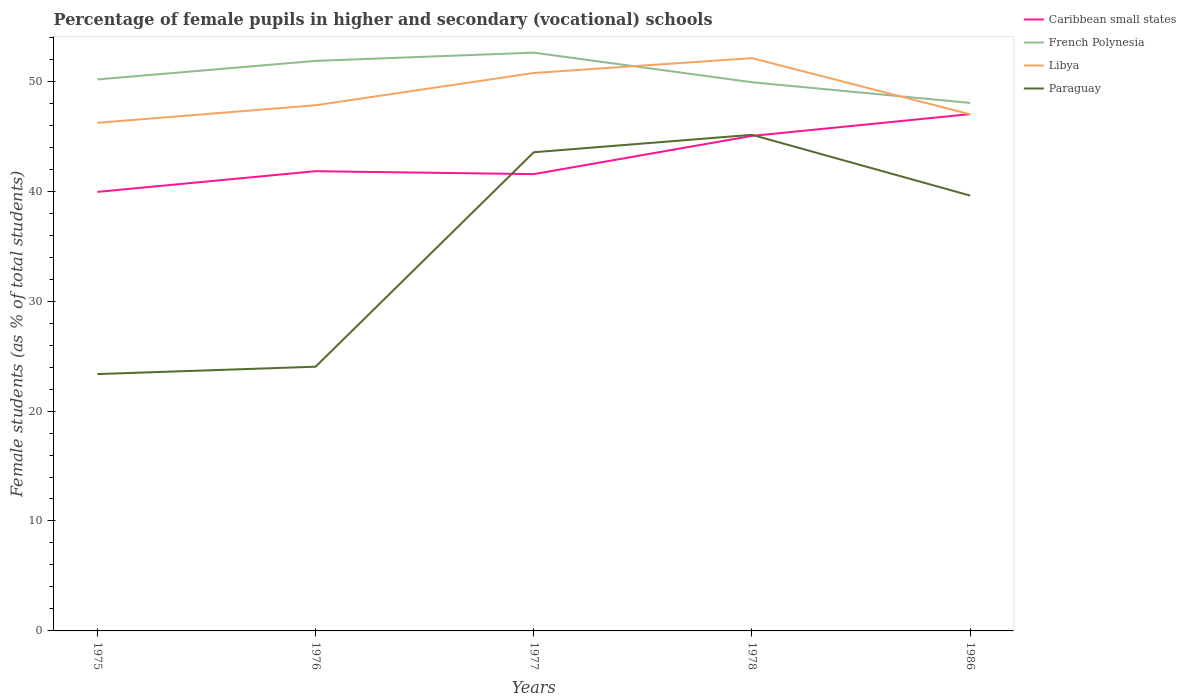Does the line corresponding to Libya intersect with the line corresponding to French Polynesia?
Offer a very short reply. Yes. Across all years, what is the maximum percentage of female pupils in higher and secondary schools in Libya?
Provide a short and direct response. 46.22. In which year was the percentage of female pupils in higher and secondary schools in French Polynesia maximum?
Your answer should be compact. 1986. What is the total percentage of female pupils in higher and secondary schools in Caribbean small states in the graph?
Provide a short and direct response. -3.21. What is the difference between the highest and the second highest percentage of female pupils in higher and secondary schools in Paraguay?
Your answer should be compact. 21.76. Is the percentage of female pupils in higher and secondary schools in Paraguay strictly greater than the percentage of female pupils in higher and secondary schools in Libya over the years?
Your answer should be very brief. Yes. Does the graph contain grids?
Keep it short and to the point. No. Where does the legend appear in the graph?
Make the answer very short. Top right. How many legend labels are there?
Your answer should be very brief. 4. What is the title of the graph?
Your answer should be very brief. Percentage of female pupils in higher and secondary (vocational) schools. What is the label or title of the Y-axis?
Offer a very short reply. Female students (as % of total students). What is the Female students (as % of total students) in Caribbean small states in 1975?
Your answer should be very brief. 39.93. What is the Female students (as % of total students) of French Polynesia in 1975?
Your answer should be compact. 50.16. What is the Female students (as % of total students) of Libya in 1975?
Ensure brevity in your answer.  46.22. What is the Female students (as % of total students) of Paraguay in 1975?
Offer a very short reply. 23.36. What is the Female students (as % of total students) in Caribbean small states in 1976?
Give a very brief answer. 41.82. What is the Female students (as % of total students) in French Polynesia in 1976?
Offer a very short reply. 51.85. What is the Female students (as % of total students) in Libya in 1976?
Provide a succinct answer. 47.82. What is the Female students (as % of total students) in Paraguay in 1976?
Offer a terse response. 24.03. What is the Female students (as % of total students) in Caribbean small states in 1977?
Your response must be concise. 41.55. What is the Female students (as % of total students) of French Polynesia in 1977?
Give a very brief answer. 52.6. What is the Female students (as % of total students) in Libya in 1977?
Provide a short and direct response. 50.75. What is the Female students (as % of total students) of Paraguay in 1977?
Your answer should be compact. 43.54. What is the Female students (as % of total students) of Caribbean small states in 1978?
Give a very brief answer. 45.03. What is the Female students (as % of total students) of French Polynesia in 1978?
Offer a terse response. 49.91. What is the Female students (as % of total students) of Libya in 1978?
Ensure brevity in your answer.  52.1. What is the Female students (as % of total students) in Paraguay in 1978?
Offer a terse response. 45.13. What is the Female students (as % of total students) in Caribbean small states in 1986?
Offer a terse response. 47.01. What is the Female students (as % of total students) in French Polynesia in 1986?
Your answer should be compact. 48.03. What is the Female students (as % of total students) of Libya in 1986?
Provide a short and direct response. 46.99. What is the Female students (as % of total students) in Paraguay in 1986?
Ensure brevity in your answer.  39.6. Across all years, what is the maximum Female students (as % of total students) of Caribbean small states?
Your answer should be compact. 47.01. Across all years, what is the maximum Female students (as % of total students) of French Polynesia?
Your answer should be compact. 52.6. Across all years, what is the maximum Female students (as % of total students) in Libya?
Your response must be concise. 52.1. Across all years, what is the maximum Female students (as % of total students) in Paraguay?
Give a very brief answer. 45.13. Across all years, what is the minimum Female students (as % of total students) of Caribbean small states?
Provide a succinct answer. 39.93. Across all years, what is the minimum Female students (as % of total students) of French Polynesia?
Your response must be concise. 48.03. Across all years, what is the minimum Female students (as % of total students) in Libya?
Keep it short and to the point. 46.22. Across all years, what is the minimum Female students (as % of total students) of Paraguay?
Keep it short and to the point. 23.36. What is the total Female students (as % of total students) of Caribbean small states in the graph?
Your response must be concise. 215.34. What is the total Female students (as % of total students) in French Polynesia in the graph?
Provide a succinct answer. 252.56. What is the total Female students (as % of total students) in Libya in the graph?
Your response must be concise. 243.88. What is the total Female students (as % of total students) of Paraguay in the graph?
Provide a succinct answer. 175.66. What is the difference between the Female students (as % of total students) in Caribbean small states in 1975 and that in 1976?
Your response must be concise. -1.88. What is the difference between the Female students (as % of total students) in French Polynesia in 1975 and that in 1976?
Your response must be concise. -1.69. What is the difference between the Female students (as % of total students) of Libya in 1975 and that in 1976?
Your answer should be compact. -1.6. What is the difference between the Female students (as % of total students) in Paraguay in 1975 and that in 1976?
Your answer should be compact. -0.67. What is the difference between the Female students (as % of total students) of Caribbean small states in 1975 and that in 1977?
Your response must be concise. -1.62. What is the difference between the Female students (as % of total students) of French Polynesia in 1975 and that in 1977?
Offer a very short reply. -2.44. What is the difference between the Female students (as % of total students) of Libya in 1975 and that in 1977?
Provide a short and direct response. -4.53. What is the difference between the Female students (as % of total students) in Paraguay in 1975 and that in 1977?
Provide a short and direct response. -20.18. What is the difference between the Female students (as % of total students) in Caribbean small states in 1975 and that in 1978?
Offer a very short reply. -5.09. What is the difference between the Female students (as % of total students) of French Polynesia in 1975 and that in 1978?
Offer a terse response. 0.25. What is the difference between the Female students (as % of total students) in Libya in 1975 and that in 1978?
Offer a very short reply. -5.88. What is the difference between the Female students (as % of total students) in Paraguay in 1975 and that in 1978?
Provide a succinct answer. -21.77. What is the difference between the Female students (as % of total students) in Caribbean small states in 1975 and that in 1986?
Provide a short and direct response. -7.08. What is the difference between the Female students (as % of total students) of French Polynesia in 1975 and that in 1986?
Provide a succinct answer. 2.14. What is the difference between the Female students (as % of total students) in Libya in 1975 and that in 1986?
Your answer should be compact. -0.77. What is the difference between the Female students (as % of total students) of Paraguay in 1975 and that in 1986?
Make the answer very short. -16.23. What is the difference between the Female students (as % of total students) of Caribbean small states in 1976 and that in 1977?
Offer a terse response. 0.27. What is the difference between the Female students (as % of total students) in French Polynesia in 1976 and that in 1977?
Give a very brief answer. -0.75. What is the difference between the Female students (as % of total students) in Libya in 1976 and that in 1977?
Offer a terse response. -2.94. What is the difference between the Female students (as % of total students) of Paraguay in 1976 and that in 1977?
Your response must be concise. -19.51. What is the difference between the Female students (as % of total students) in Caribbean small states in 1976 and that in 1978?
Your response must be concise. -3.21. What is the difference between the Female students (as % of total students) of French Polynesia in 1976 and that in 1978?
Your response must be concise. 1.94. What is the difference between the Female students (as % of total students) in Libya in 1976 and that in 1978?
Provide a short and direct response. -4.29. What is the difference between the Female students (as % of total students) in Paraguay in 1976 and that in 1978?
Offer a very short reply. -21.09. What is the difference between the Female students (as % of total students) in Caribbean small states in 1976 and that in 1986?
Offer a very short reply. -5.19. What is the difference between the Female students (as % of total students) of French Polynesia in 1976 and that in 1986?
Provide a short and direct response. 3.82. What is the difference between the Female students (as % of total students) in Libya in 1976 and that in 1986?
Your answer should be very brief. 0.83. What is the difference between the Female students (as % of total students) in Paraguay in 1976 and that in 1986?
Offer a terse response. -15.56. What is the difference between the Female students (as % of total students) in Caribbean small states in 1977 and that in 1978?
Keep it short and to the point. -3.48. What is the difference between the Female students (as % of total students) in French Polynesia in 1977 and that in 1978?
Offer a very short reply. 2.69. What is the difference between the Female students (as % of total students) of Libya in 1977 and that in 1978?
Ensure brevity in your answer.  -1.35. What is the difference between the Female students (as % of total students) of Paraguay in 1977 and that in 1978?
Make the answer very short. -1.59. What is the difference between the Female students (as % of total students) of Caribbean small states in 1977 and that in 1986?
Provide a succinct answer. -5.46. What is the difference between the Female students (as % of total students) of French Polynesia in 1977 and that in 1986?
Your response must be concise. 4.57. What is the difference between the Female students (as % of total students) of Libya in 1977 and that in 1986?
Offer a very short reply. 3.76. What is the difference between the Female students (as % of total students) of Paraguay in 1977 and that in 1986?
Provide a short and direct response. 3.94. What is the difference between the Female students (as % of total students) of Caribbean small states in 1978 and that in 1986?
Your response must be concise. -1.98. What is the difference between the Female students (as % of total students) of French Polynesia in 1978 and that in 1986?
Offer a very short reply. 1.88. What is the difference between the Female students (as % of total students) of Libya in 1978 and that in 1986?
Ensure brevity in your answer.  5.11. What is the difference between the Female students (as % of total students) in Paraguay in 1978 and that in 1986?
Ensure brevity in your answer.  5.53. What is the difference between the Female students (as % of total students) of Caribbean small states in 1975 and the Female students (as % of total students) of French Polynesia in 1976?
Ensure brevity in your answer.  -11.92. What is the difference between the Female students (as % of total students) in Caribbean small states in 1975 and the Female students (as % of total students) in Libya in 1976?
Ensure brevity in your answer.  -7.88. What is the difference between the Female students (as % of total students) of Caribbean small states in 1975 and the Female students (as % of total students) of Paraguay in 1976?
Ensure brevity in your answer.  15.9. What is the difference between the Female students (as % of total students) in French Polynesia in 1975 and the Female students (as % of total students) in Libya in 1976?
Provide a short and direct response. 2.35. What is the difference between the Female students (as % of total students) of French Polynesia in 1975 and the Female students (as % of total students) of Paraguay in 1976?
Make the answer very short. 26.13. What is the difference between the Female students (as % of total students) of Libya in 1975 and the Female students (as % of total students) of Paraguay in 1976?
Your response must be concise. 22.19. What is the difference between the Female students (as % of total students) in Caribbean small states in 1975 and the Female students (as % of total students) in French Polynesia in 1977?
Ensure brevity in your answer.  -12.67. What is the difference between the Female students (as % of total students) in Caribbean small states in 1975 and the Female students (as % of total students) in Libya in 1977?
Your answer should be compact. -10.82. What is the difference between the Female students (as % of total students) of Caribbean small states in 1975 and the Female students (as % of total students) of Paraguay in 1977?
Your answer should be compact. -3.61. What is the difference between the Female students (as % of total students) of French Polynesia in 1975 and the Female students (as % of total students) of Libya in 1977?
Your answer should be compact. -0.59. What is the difference between the Female students (as % of total students) of French Polynesia in 1975 and the Female students (as % of total students) of Paraguay in 1977?
Provide a short and direct response. 6.62. What is the difference between the Female students (as % of total students) in Libya in 1975 and the Female students (as % of total students) in Paraguay in 1977?
Ensure brevity in your answer.  2.68. What is the difference between the Female students (as % of total students) in Caribbean small states in 1975 and the Female students (as % of total students) in French Polynesia in 1978?
Provide a succinct answer. -9.98. What is the difference between the Female students (as % of total students) in Caribbean small states in 1975 and the Female students (as % of total students) in Libya in 1978?
Ensure brevity in your answer.  -12.17. What is the difference between the Female students (as % of total students) in Caribbean small states in 1975 and the Female students (as % of total students) in Paraguay in 1978?
Ensure brevity in your answer.  -5.19. What is the difference between the Female students (as % of total students) in French Polynesia in 1975 and the Female students (as % of total students) in Libya in 1978?
Offer a terse response. -1.94. What is the difference between the Female students (as % of total students) of French Polynesia in 1975 and the Female students (as % of total students) of Paraguay in 1978?
Your response must be concise. 5.04. What is the difference between the Female students (as % of total students) of Libya in 1975 and the Female students (as % of total students) of Paraguay in 1978?
Offer a terse response. 1.09. What is the difference between the Female students (as % of total students) in Caribbean small states in 1975 and the Female students (as % of total students) in French Polynesia in 1986?
Offer a terse response. -8.09. What is the difference between the Female students (as % of total students) of Caribbean small states in 1975 and the Female students (as % of total students) of Libya in 1986?
Provide a succinct answer. -7.06. What is the difference between the Female students (as % of total students) of Caribbean small states in 1975 and the Female students (as % of total students) of Paraguay in 1986?
Your answer should be compact. 0.34. What is the difference between the Female students (as % of total students) of French Polynesia in 1975 and the Female students (as % of total students) of Libya in 1986?
Ensure brevity in your answer.  3.17. What is the difference between the Female students (as % of total students) of French Polynesia in 1975 and the Female students (as % of total students) of Paraguay in 1986?
Your answer should be very brief. 10.57. What is the difference between the Female students (as % of total students) of Libya in 1975 and the Female students (as % of total students) of Paraguay in 1986?
Ensure brevity in your answer.  6.62. What is the difference between the Female students (as % of total students) in Caribbean small states in 1976 and the Female students (as % of total students) in French Polynesia in 1977?
Your answer should be very brief. -10.78. What is the difference between the Female students (as % of total students) of Caribbean small states in 1976 and the Female students (as % of total students) of Libya in 1977?
Provide a short and direct response. -8.93. What is the difference between the Female students (as % of total students) in Caribbean small states in 1976 and the Female students (as % of total students) in Paraguay in 1977?
Offer a terse response. -1.72. What is the difference between the Female students (as % of total students) in French Polynesia in 1976 and the Female students (as % of total students) in Libya in 1977?
Offer a terse response. 1.1. What is the difference between the Female students (as % of total students) in French Polynesia in 1976 and the Female students (as % of total students) in Paraguay in 1977?
Give a very brief answer. 8.31. What is the difference between the Female students (as % of total students) in Libya in 1976 and the Female students (as % of total students) in Paraguay in 1977?
Offer a terse response. 4.27. What is the difference between the Female students (as % of total students) of Caribbean small states in 1976 and the Female students (as % of total students) of French Polynesia in 1978?
Offer a very short reply. -8.09. What is the difference between the Female students (as % of total students) in Caribbean small states in 1976 and the Female students (as % of total students) in Libya in 1978?
Offer a very short reply. -10.29. What is the difference between the Female students (as % of total students) in Caribbean small states in 1976 and the Female students (as % of total students) in Paraguay in 1978?
Offer a terse response. -3.31. What is the difference between the Female students (as % of total students) of French Polynesia in 1976 and the Female students (as % of total students) of Libya in 1978?
Keep it short and to the point. -0.25. What is the difference between the Female students (as % of total students) of French Polynesia in 1976 and the Female students (as % of total students) of Paraguay in 1978?
Ensure brevity in your answer.  6.72. What is the difference between the Female students (as % of total students) of Libya in 1976 and the Female students (as % of total students) of Paraguay in 1978?
Provide a succinct answer. 2.69. What is the difference between the Female students (as % of total students) of Caribbean small states in 1976 and the Female students (as % of total students) of French Polynesia in 1986?
Your response must be concise. -6.21. What is the difference between the Female students (as % of total students) of Caribbean small states in 1976 and the Female students (as % of total students) of Libya in 1986?
Make the answer very short. -5.17. What is the difference between the Female students (as % of total students) in Caribbean small states in 1976 and the Female students (as % of total students) in Paraguay in 1986?
Provide a short and direct response. 2.22. What is the difference between the Female students (as % of total students) in French Polynesia in 1976 and the Female students (as % of total students) in Libya in 1986?
Give a very brief answer. 4.86. What is the difference between the Female students (as % of total students) of French Polynesia in 1976 and the Female students (as % of total students) of Paraguay in 1986?
Your answer should be compact. 12.25. What is the difference between the Female students (as % of total students) in Libya in 1976 and the Female students (as % of total students) in Paraguay in 1986?
Your answer should be very brief. 8.22. What is the difference between the Female students (as % of total students) in Caribbean small states in 1977 and the Female students (as % of total students) in French Polynesia in 1978?
Keep it short and to the point. -8.36. What is the difference between the Female students (as % of total students) of Caribbean small states in 1977 and the Female students (as % of total students) of Libya in 1978?
Your answer should be compact. -10.55. What is the difference between the Female students (as % of total students) in Caribbean small states in 1977 and the Female students (as % of total students) in Paraguay in 1978?
Provide a short and direct response. -3.58. What is the difference between the Female students (as % of total students) in French Polynesia in 1977 and the Female students (as % of total students) in Libya in 1978?
Give a very brief answer. 0.5. What is the difference between the Female students (as % of total students) of French Polynesia in 1977 and the Female students (as % of total students) of Paraguay in 1978?
Your answer should be compact. 7.47. What is the difference between the Female students (as % of total students) in Libya in 1977 and the Female students (as % of total students) in Paraguay in 1978?
Your answer should be very brief. 5.62. What is the difference between the Female students (as % of total students) of Caribbean small states in 1977 and the Female students (as % of total students) of French Polynesia in 1986?
Ensure brevity in your answer.  -6.48. What is the difference between the Female students (as % of total students) of Caribbean small states in 1977 and the Female students (as % of total students) of Libya in 1986?
Your answer should be compact. -5.44. What is the difference between the Female students (as % of total students) of Caribbean small states in 1977 and the Female students (as % of total students) of Paraguay in 1986?
Make the answer very short. 1.95. What is the difference between the Female students (as % of total students) of French Polynesia in 1977 and the Female students (as % of total students) of Libya in 1986?
Offer a terse response. 5.61. What is the difference between the Female students (as % of total students) in French Polynesia in 1977 and the Female students (as % of total students) in Paraguay in 1986?
Your response must be concise. 13. What is the difference between the Female students (as % of total students) of Libya in 1977 and the Female students (as % of total students) of Paraguay in 1986?
Offer a terse response. 11.15. What is the difference between the Female students (as % of total students) of Caribbean small states in 1978 and the Female students (as % of total students) of French Polynesia in 1986?
Give a very brief answer. -3. What is the difference between the Female students (as % of total students) of Caribbean small states in 1978 and the Female students (as % of total students) of Libya in 1986?
Offer a terse response. -1.96. What is the difference between the Female students (as % of total students) of Caribbean small states in 1978 and the Female students (as % of total students) of Paraguay in 1986?
Offer a terse response. 5.43. What is the difference between the Female students (as % of total students) of French Polynesia in 1978 and the Female students (as % of total students) of Libya in 1986?
Your response must be concise. 2.92. What is the difference between the Female students (as % of total students) of French Polynesia in 1978 and the Female students (as % of total students) of Paraguay in 1986?
Keep it short and to the point. 10.31. What is the difference between the Female students (as % of total students) in Libya in 1978 and the Female students (as % of total students) in Paraguay in 1986?
Keep it short and to the point. 12.51. What is the average Female students (as % of total students) of Caribbean small states per year?
Keep it short and to the point. 43.07. What is the average Female students (as % of total students) of French Polynesia per year?
Your answer should be compact. 50.51. What is the average Female students (as % of total students) in Libya per year?
Your answer should be very brief. 48.78. What is the average Female students (as % of total students) in Paraguay per year?
Keep it short and to the point. 35.13. In the year 1975, what is the difference between the Female students (as % of total students) of Caribbean small states and Female students (as % of total students) of French Polynesia?
Your answer should be compact. -10.23. In the year 1975, what is the difference between the Female students (as % of total students) in Caribbean small states and Female students (as % of total students) in Libya?
Ensure brevity in your answer.  -6.28. In the year 1975, what is the difference between the Female students (as % of total students) of Caribbean small states and Female students (as % of total students) of Paraguay?
Your answer should be compact. 16.57. In the year 1975, what is the difference between the Female students (as % of total students) in French Polynesia and Female students (as % of total students) in Libya?
Provide a short and direct response. 3.95. In the year 1975, what is the difference between the Female students (as % of total students) of French Polynesia and Female students (as % of total students) of Paraguay?
Make the answer very short. 26.8. In the year 1975, what is the difference between the Female students (as % of total students) in Libya and Female students (as % of total students) in Paraguay?
Your answer should be compact. 22.86. In the year 1976, what is the difference between the Female students (as % of total students) of Caribbean small states and Female students (as % of total students) of French Polynesia?
Provide a succinct answer. -10.03. In the year 1976, what is the difference between the Female students (as % of total students) of Caribbean small states and Female students (as % of total students) of Libya?
Ensure brevity in your answer.  -6. In the year 1976, what is the difference between the Female students (as % of total students) of Caribbean small states and Female students (as % of total students) of Paraguay?
Provide a short and direct response. 17.78. In the year 1976, what is the difference between the Female students (as % of total students) of French Polynesia and Female students (as % of total students) of Libya?
Provide a succinct answer. 4.04. In the year 1976, what is the difference between the Female students (as % of total students) in French Polynesia and Female students (as % of total students) in Paraguay?
Provide a short and direct response. 27.82. In the year 1976, what is the difference between the Female students (as % of total students) of Libya and Female students (as % of total students) of Paraguay?
Your response must be concise. 23.78. In the year 1977, what is the difference between the Female students (as % of total students) of Caribbean small states and Female students (as % of total students) of French Polynesia?
Make the answer very short. -11.05. In the year 1977, what is the difference between the Female students (as % of total students) in Caribbean small states and Female students (as % of total students) in Libya?
Ensure brevity in your answer.  -9.2. In the year 1977, what is the difference between the Female students (as % of total students) of Caribbean small states and Female students (as % of total students) of Paraguay?
Give a very brief answer. -1.99. In the year 1977, what is the difference between the Female students (as % of total students) of French Polynesia and Female students (as % of total students) of Libya?
Keep it short and to the point. 1.85. In the year 1977, what is the difference between the Female students (as % of total students) in French Polynesia and Female students (as % of total students) in Paraguay?
Make the answer very short. 9.06. In the year 1977, what is the difference between the Female students (as % of total students) of Libya and Female students (as % of total students) of Paraguay?
Your answer should be very brief. 7.21. In the year 1978, what is the difference between the Female students (as % of total students) of Caribbean small states and Female students (as % of total students) of French Polynesia?
Make the answer very short. -4.88. In the year 1978, what is the difference between the Female students (as % of total students) of Caribbean small states and Female students (as % of total students) of Libya?
Keep it short and to the point. -7.08. In the year 1978, what is the difference between the Female students (as % of total students) in Caribbean small states and Female students (as % of total students) in Paraguay?
Offer a very short reply. -0.1. In the year 1978, what is the difference between the Female students (as % of total students) in French Polynesia and Female students (as % of total students) in Libya?
Offer a very short reply. -2.19. In the year 1978, what is the difference between the Female students (as % of total students) of French Polynesia and Female students (as % of total students) of Paraguay?
Ensure brevity in your answer.  4.78. In the year 1978, what is the difference between the Female students (as % of total students) of Libya and Female students (as % of total students) of Paraguay?
Offer a terse response. 6.98. In the year 1986, what is the difference between the Female students (as % of total students) in Caribbean small states and Female students (as % of total students) in French Polynesia?
Keep it short and to the point. -1.02. In the year 1986, what is the difference between the Female students (as % of total students) in Caribbean small states and Female students (as % of total students) in Libya?
Your answer should be very brief. 0.02. In the year 1986, what is the difference between the Female students (as % of total students) in Caribbean small states and Female students (as % of total students) in Paraguay?
Offer a very short reply. 7.41. In the year 1986, what is the difference between the Female students (as % of total students) in French Polynesia and Female students (as % of total students) in Libya?
Offer a very short reply. 1.04. In the year 1986, what is the difference between the Female students (as % of total students) in French Polynesia and Female students (as % of total students) in Paraguay?
Ensure brevity in your answer.  8.43. In the year 1986, what is the difference between the Female students (as % of total students) in Libya and Female students (as % of total students) in Paraguay?
Give a very brief answer. 7.39. What is the ratio of the Female students (as % of total students) in Caribbean small states in 1975 to that in 1976?
Offer a terse response. 0.95. What is the ratio of the Female students (as % of total students) in French Polynesia in 1975 to that in 1976?
Your response must be concise. 0.97. What is the ratio of the Female students (as % of total students) in Libya in 1975 to that in 1976?
Provide a succinct answer. 0.97. What is the ratio of the Female students (as % of total students) in Paraguay in 1975 to that in 1976?
Make the answer very short. 0.97. What is the ratio of the Female students (as % of total students) of Caribbean small states in 1975 to that in 1977?
Offer a terse response. 0.96. What is the ratio of the Female students (as % of total students) of French Polynesia in 1975 to that in 1977?
Your answer should be very brief. 0.95. What is the ratio of the Female students (as % of total students) in Libya in 1975 to that in 1977?
Your answer should be compact. 0.91. What is the ratio of the Female students (as % of total students) of Paraguay in 1975 to that in 1977?
Give a very brief answer. 0.54. What is the ratio of the Female students (as % of total students) of Caribbean small states in 1975 to that in 1978?
Your answer should be very brief. 0.89. What is the ratio of the Female students (as % of total students) of Libya in 1975 to that in 1978?
Offer a terse response. 0.89. What is the ratio of the Female students (as % of total students) of Paraguay in 1975 to that in 1978?
Keep it short and to the point. 0.52. What is the ratio of the Female students (as % of total students) in Caribbean small states in 1975 to that in 1986?
Your answer should be very brief. 0.85. What is the ratio of the Female students (as % of total students) in French Polynesia in 1975 to that in 1986?
Provide a succinct answer. 1.04. What is the ratio of the Female students (as % of total students) in Libya in 1975 to that in 1986?
Make the answer very short. 0.98. What is the ratio of the Female students (as % of total students) of Paraguay in 1975 to that in 1986?
Offer a terse response. 0.59. What is the ratio of the Female students (as % of total students) of Caribbean small states in 1976 to that in 1977?
Offer a very short reply. 1.01. What is the ratio of the Female students (as % of total students) of French Polynesia in 1976 to that in 1977?
Your answer should be compact. 0.99. What is the ratio of the Female students (as % of total students) in Libya in 1976 to that in 1977?
Offer a very short reply. 0.94. What is the ratio of the Female students (as % of total students) in Paraguay in 1976 to that in 1977?
Ensure brevity in your answer.  0.55. What is the ratio of the Female students (as % of total students) in Caribbean small states in 1976 to that in 1978?
Provide a short and direct response. 0.93. What is the ratio of the Female students (as % of total students) of French Polynesia in 1976 to that in 1978?
Provide a succinct answer. 1.04. What is the ratio of the Female students (as % of total students) in Libya in 1976 to that in 1978?
Provide a succinct answer. 0.92. What is the ratio of the Female students (as % of total students) in Paraguay in 1976 to that in 1978?
Offer a very short reply. 0.53. What is the ratio of the Female students (as % of total students) in Caribbean small states in 1976 to that in 1986?
Make the answer very short. 0.89. What is the ratio of the Female students (as % of total students) in French Polynesia in 1976 to that in 1986?
Provide a succinct answer. 1.08. What is the ratio of the Female students (as % of total students) in Libya in 1976 to that in 1986?
Your answer should be very brief. 1.02. What is the ratio of the Female students (as % of total students) in Paraguay in 1976 to that in 1986?
Keep it short and to the point. 0.61. What is the ratio of the Female students (as % of total students) of Caribbean small states in 1977 to that in 1978?
Provide a succinct answer. 0.92. What is the ratio of the Female students (as % of total students) of French Polynesia in 1977 to that in 1978?
Offer a terse response. 1.05. What is the ratio of the Female students (as % of total students) in Libya in 1977 to that in 1978?
Keep it short and to the point. 0.97. What is the ratio of the Female students (as % of total students) in Paraguay in 1977 to that in 1978?
Provide a short and direct response. 0.96. What is the ratio of the Female students (as % of total students) of Caribbean small states in 1977 to that in 1986?
Offer a terse response. 0.88. What is the ratio of the Female students (as % of total students) of French Polynesia in 1977 to that in 1986?
Offer a very short reply. 1.1. What is the ratio of the Female students (as % of total students) in Libya in 1977 to that in 1986?
Ensure brevity in your answer.  1.08. What is the ratio of the Female students (as % of total students) of Paraguay in 1977 to that in 1986?
Your answer should be very brief. 1.1. What is the ratio of the Female students (as % of total students) of Caribbean small states in 1978 to that in 1986?
Offer a very short reply. 0.96. What is the ratio of the Female students (as % of total students) in French Polynesia in 1978 to that in 1986?
Your response must be concise. 1.04. What is the ratio of the Female students (as % of total students) of Libya in 1978 to that in 1986?
Ensure brevity in your answer.  1.11. What is the ratio of the Female students (as % of total students) of Paraguay in 1978 to that in 1986?
Provide a succinct answer. 1.14. What is the difference between the highest and the second highest Female students (as % of total students) in Caribbean small states?
Ensure brevity in your answer.  1.98. What is the difference between the highest and the second highest Female students (as % of total students) in French Polynesia?
Your response must be concise. 0.75. What is the difference between the highest and the second highest Female students (as % of total students) in Libya?
Your answer should be very brief. 1.35. What is the difference between the highest and the second highest Female students (as % of total students) of Paraguay?
Keep it short and to the point. 1.59. What is the difference between the highest and the lowest Female students (as % of total students) of Caribbean small states?
Make the answer very short. 7.08. What is the difference between the highest and the lowest Female students (as % of total students) of French Polynesia?
Your answer should be very brief. 4.57. What is the difference between the highest and the lowest Female students (as % of total students) of Libya?
Your response must be concise. 5.88. What is the difference between the highest and the lowest Female students (as % of total students) in Paraguay?
Your answer should be compact. 21.77. 